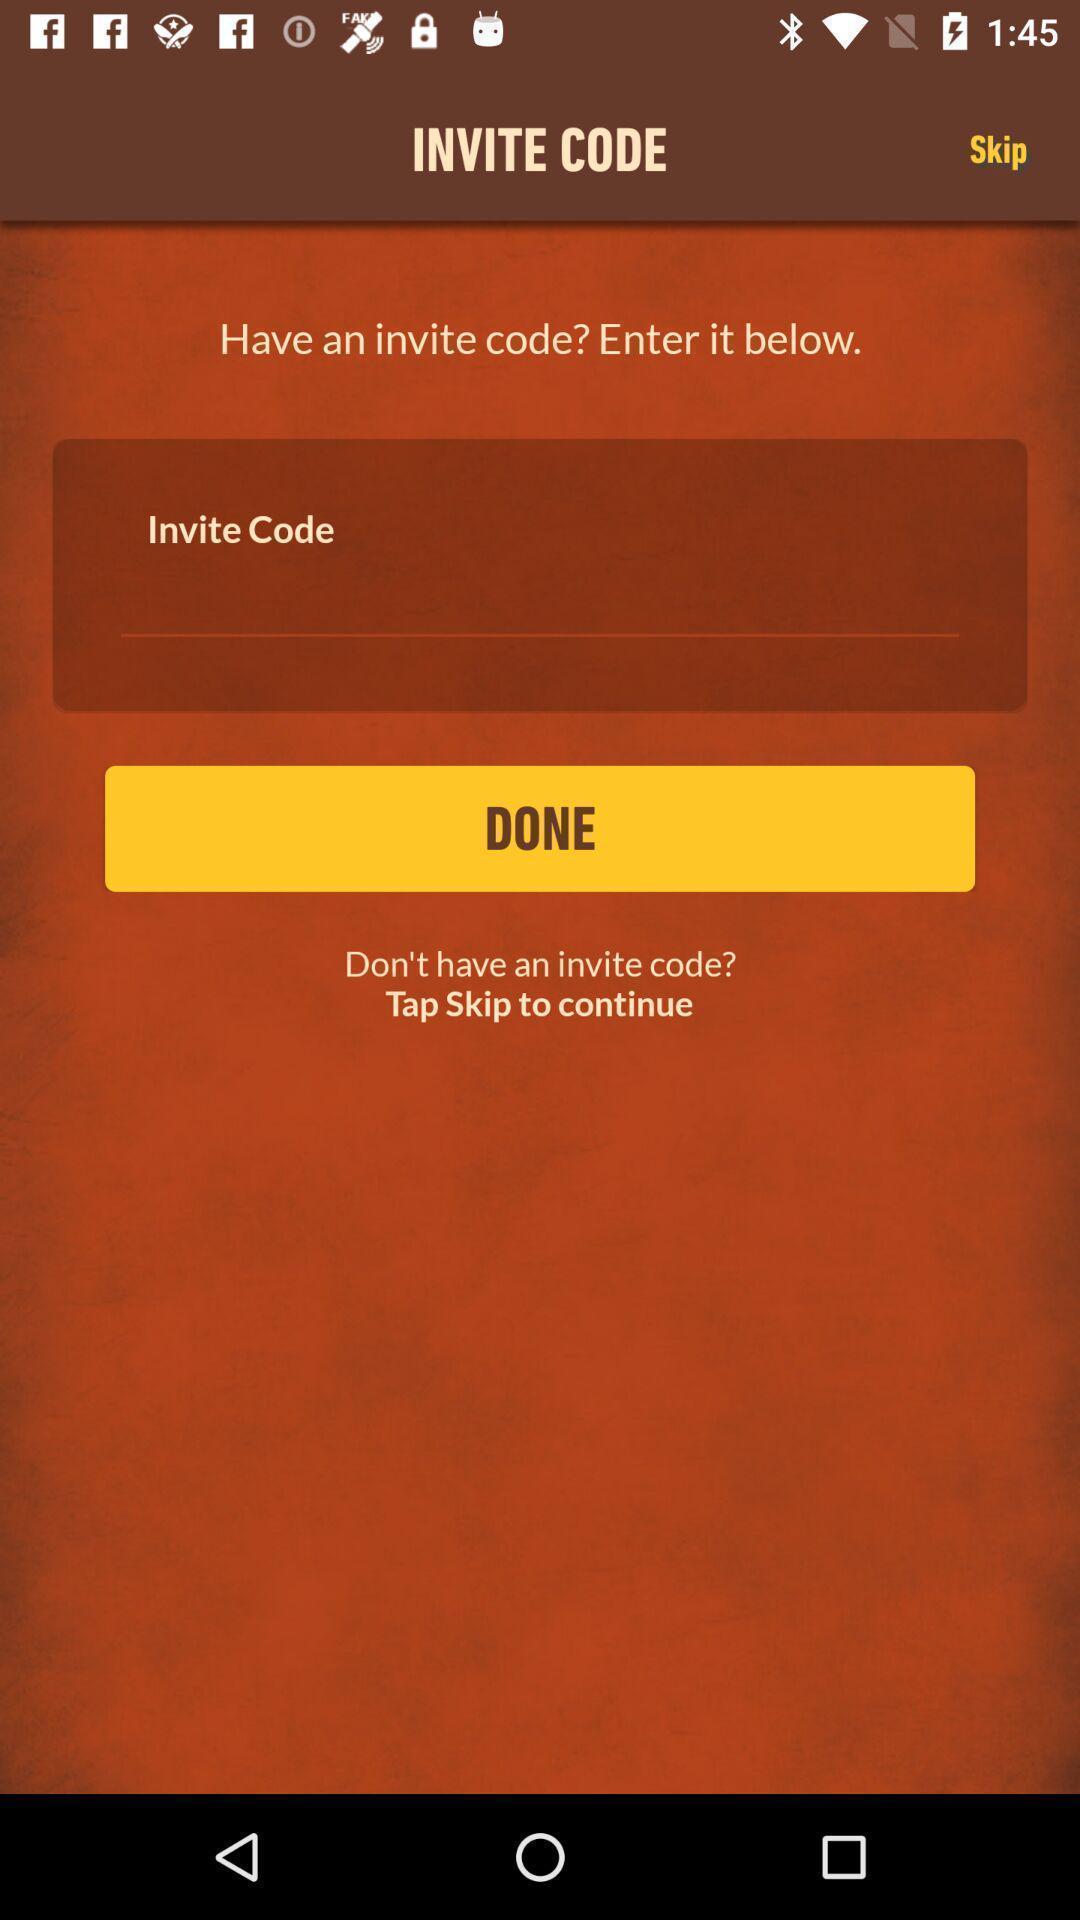Provide a description of this screenshot. Screen displaying coupon code option. 